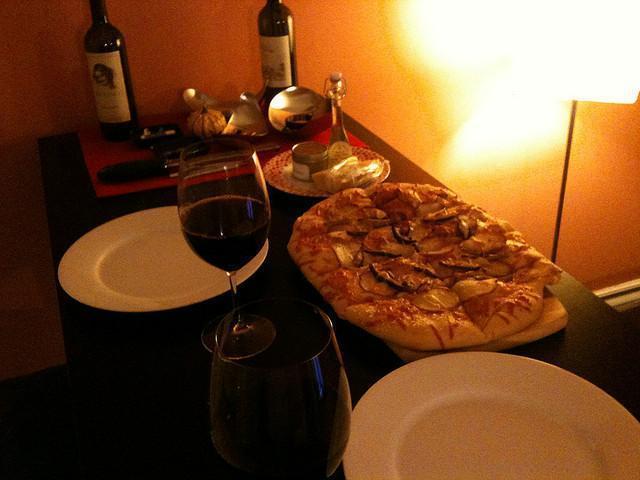How many people can sit at this meal?
Give a very brief answer. 2. How many place settings are at the table?
Give a very brief answer. 2. How many bottles are on the table?
Give a very brief answer. 2. How many bottles are there?
Give a very brief answer. 2. How many dining tables are there?
Give a very brief answer. 1. How many wine glasses can be seen?
Give a very brief answer. 2. How many benches are there?
Give a very brief answer. 0. 